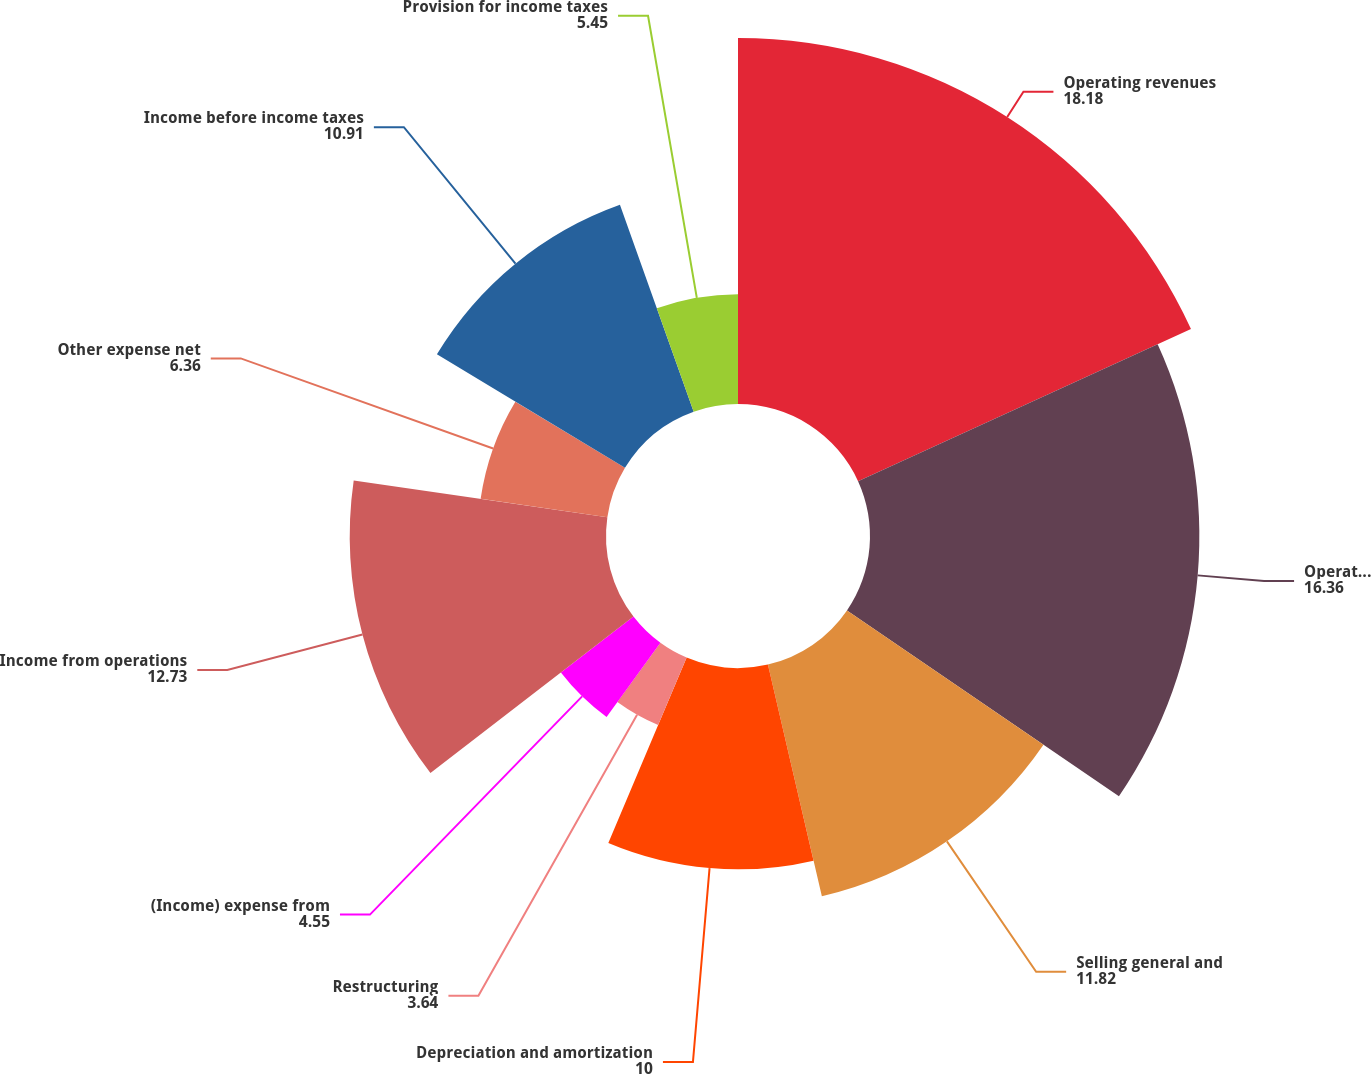Convert chart. <chart><loc_0><loc_0><loc_500><loc_500><pie_chart><fcel>Operating revenues<fcel>Operating<fcel>Selling general and<fcel>Depreciation and amortization<fcel>Restructuring<fcel>(Income) expense from<fcel>Income from operations<fcel>Other expense net<fcel>Income before income taxes<fcel>Provision for income taxes<nl><fcel>18.18%<fcel>16.36%<fcel>11.82%<fcel>10.0%<fcel>3.64%<fcel>4.55%<fcel>12.73%<fcel>6.36%<fcel>10.91%<fcel>5.45%<nl></chart> 